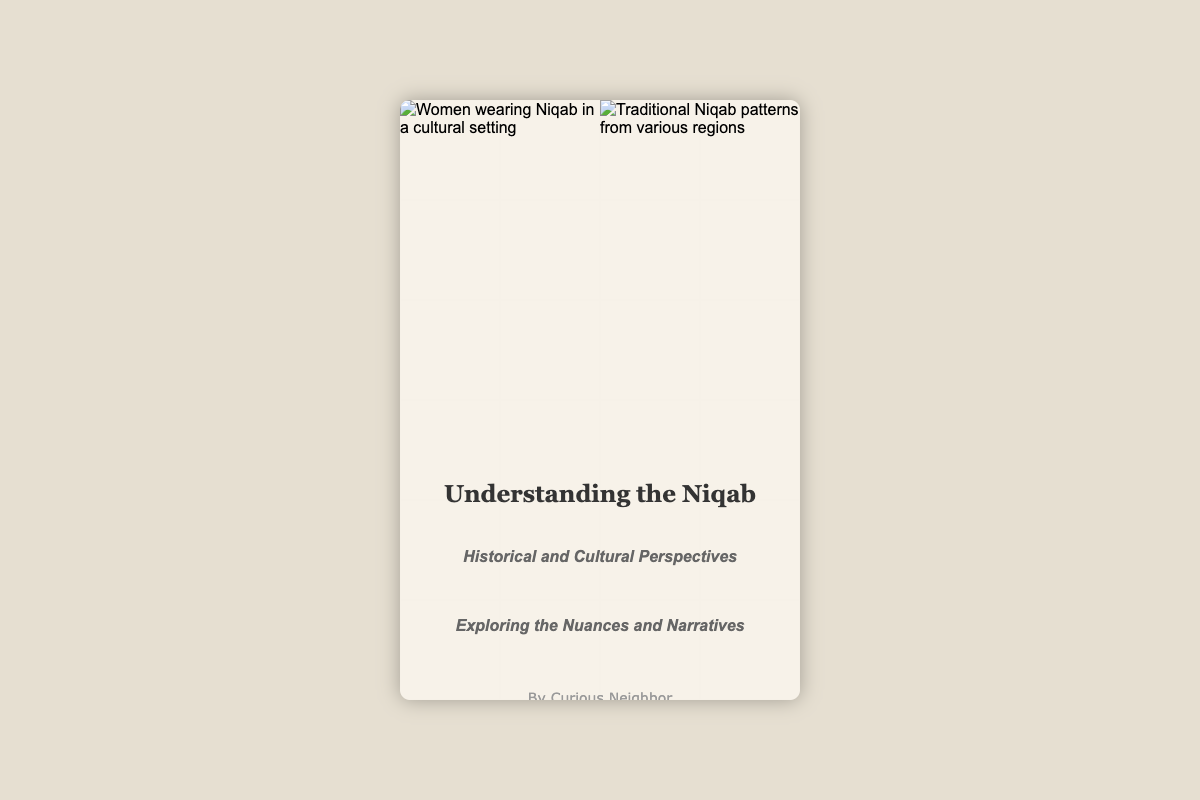What is the title of the book? The title of the book is located prominently at the top of the document.
Answer: Understanding the Niqab Who is the author of the book? The author's name is displayed in the author's section of the document.
Answer: Curious Neighbor What is the subtitle of the book? The subtitle provides additional context about the book's content and is situated below the title.
Answer: Historical and Cultural Perspectives How many images are included in the cover design? The images are visible in the image container section of the document, with two distinct images shown.
Answer: Two What themes does the book cover explore? The themes are indicated in a subtitle that highlights the book's focus.
Answer: Nuances and Narratives What type of document is this? The document is specifically designed as a book cover, which is evident from its structure and content.
Answer: Book cover What is the background color of the book cover? The background color can be seen clearly as part of the document styling.
Answer: Light beige What is the font style of the book title? The font style can be identified in the styling section of the document, specifically for the title.
Answer: Georgia 